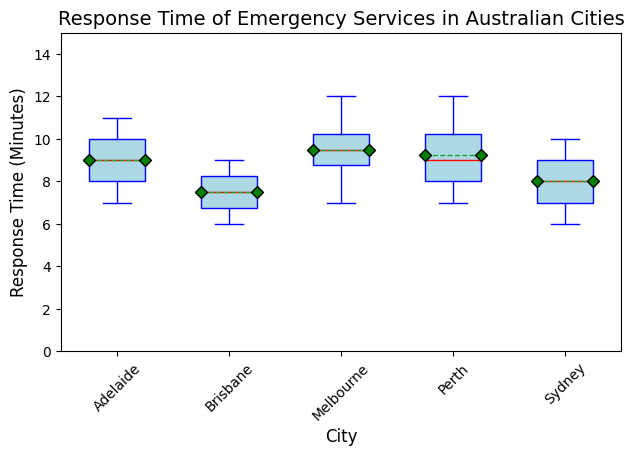1. Which city has the lowest median response time? By examining the box plot, locate the median line (usually marked in red) for each city and identify the lowest one.
Answer: Brisbane 2. What is the interquartile range (IQR) of response times in Sydney? Calculate the IQR by finding the difference between the third quartile (Q3) and the first quartile (Q1). The upper and lower edges of the box represent Q3 and Q1, respectively.
Answer: 3 3. How does the average response time in Melbourne compare to that in Perth? Locate the mean markers (green diamond shapes) for Melbourne and Perth and compare their positions vertically on the y-axis.
Answer: Melbourne's average response time is higher 4. Among the cities listed, which has the most variability in response times? Variability is indicated by the length of the whiskers and the spread of the data points. Look for the city with the tallest overall box and whiskers.
Answer: Perth 5. Do any of the cities have outliers in their response times, and if so, which ones? Outliers are represented by individual points outside the whiskers; count these red circles for each city.
Answer: Yes, Sydney and Melbourne 6. What is the range of response times observed in Adelaide? The range can be calculated by subtracting the smallest value within the whiskers from the largest value.
Answer: 4 7. Which city's emergency services have the fastest median response time, and by how much is it faster than Melbourne's median? Find the cities' median response times and subtract Melbourne's median time from the fastest city's median.
Answer: Brisbane, 2 minutes 8. Compare the spread of response times in Brisbane to that in Sydney. Evaluate the length of the boxes and whiskers for both cities to determine the spread.
Answer: Brisbane has a slightly smaller spread 9. What is the median response time in Perth, and how does it compare to the average response time in Brisbane? Identify the median line in Perth's box plot and compare it with Brisbane's mean marker.
Answer: Perth's median is 9 minutes, which is higher compared to Brisbane's average 10. Which city's emergency services have the most consistent (least variable) response times? Consistency is indicated by the shortest box and whiskers; identify the city with the smallest spread.
Answer: Brisbane 